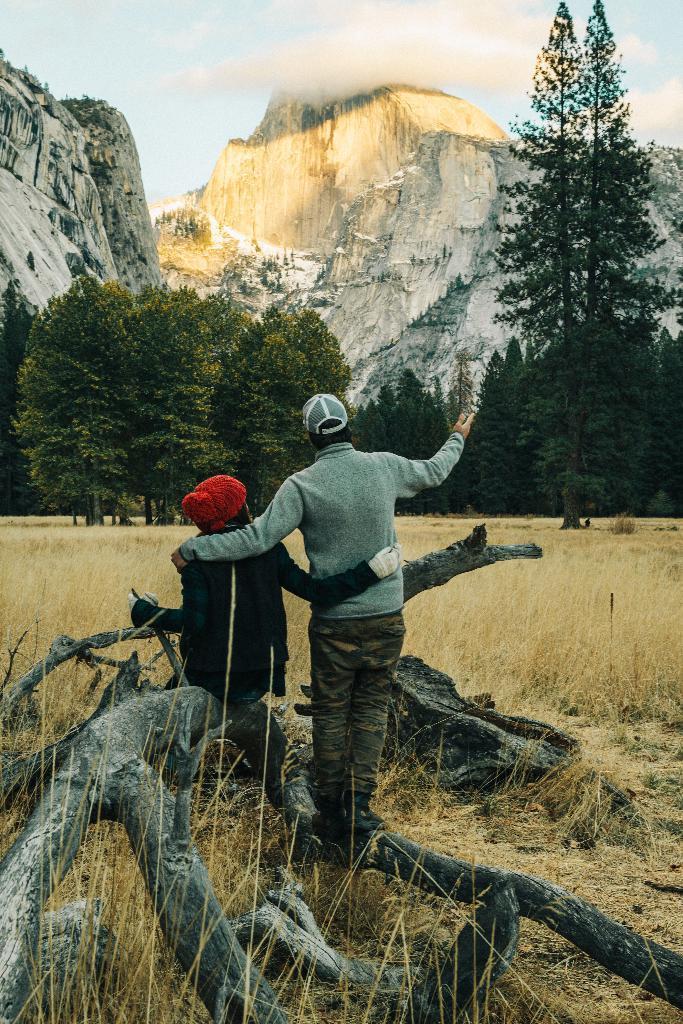Please provide a concise description of this image. In the image there are tree trunks and two people. In front of them there's grass on the ground. In the background there are trees and hills. At the top of the image there is a sky. 